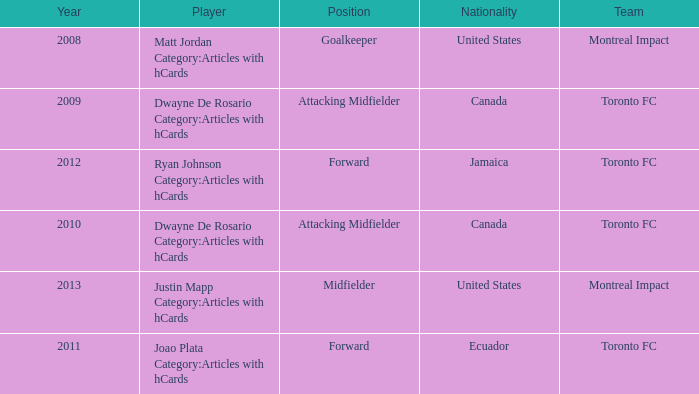After 2009, what's the nationality of a player named Dwayne de Rosario Category:articles with hcards? Canada. 